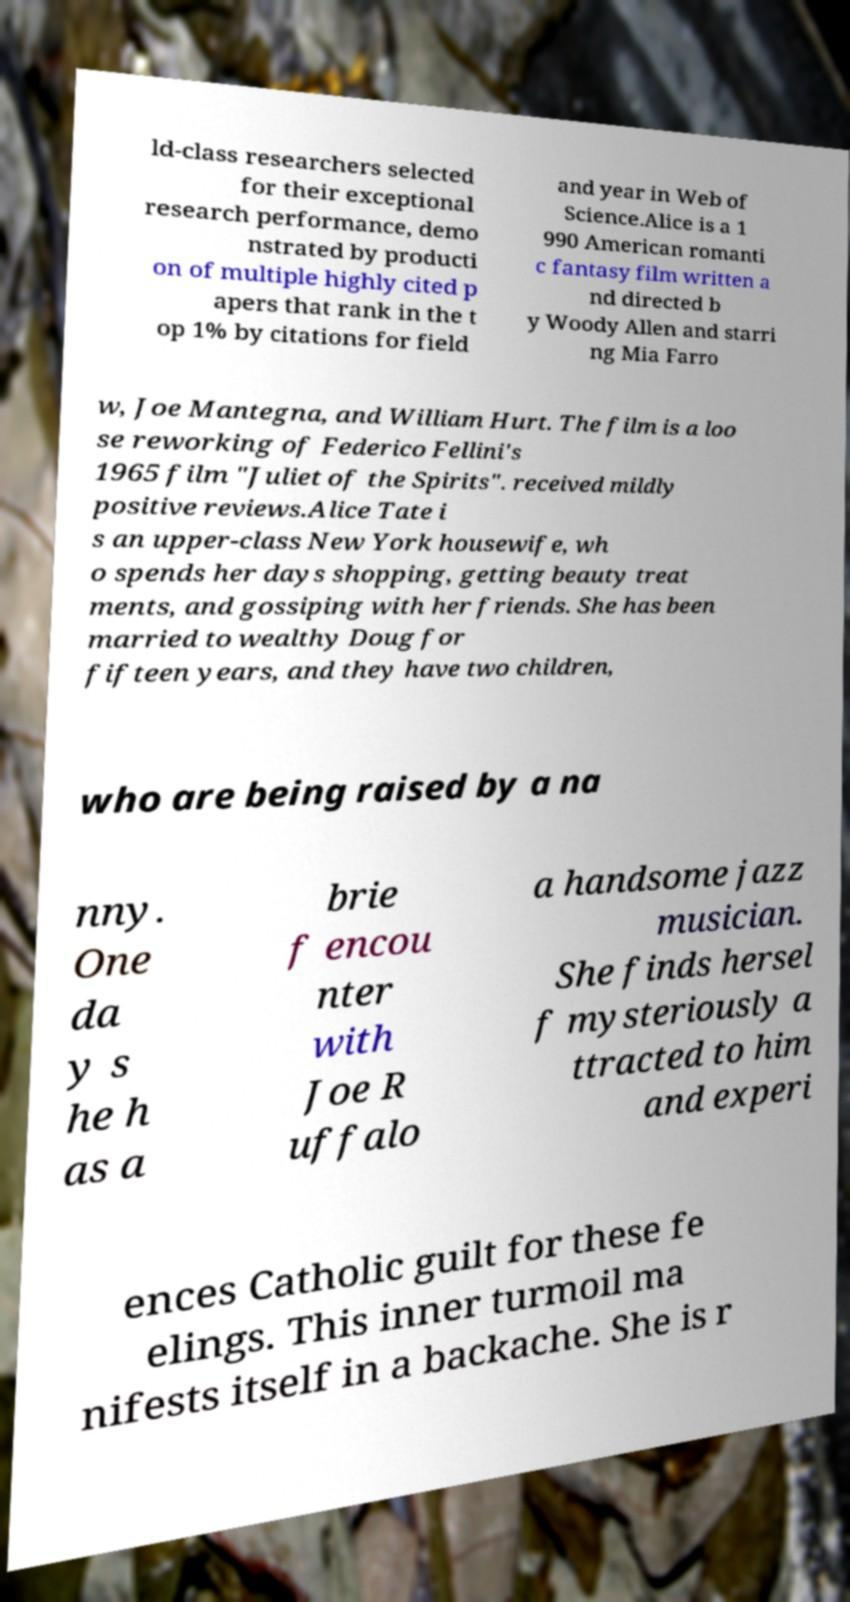Could you extract and type out the text from this image? ld-class researchers selected for their exceptional research performance, demo nstrated by producti on of multiple highly cited p apers that rank in the t op 1% by citations for field and year in Web of Science.Alice is a 1 990 American romanti c fantasy film written a nd directed b y Woody Allen and starri ng Mia Farro w, Joe Mantegna, and William Hurt. The film is a loo se reworking of Federico Fellini's 1965 film "Juliet of the Spirits". received mildly positive reviews.Alice Tate i s an upper-class New York housewife, wh o spends her days shopping, getting beauty treat ments, and gossiping with her friends. She has been married to wealthy Doug for fifteen years, and they have two children, who are being raised by a na nny. One da y s he h as a brie f encou nter with Joe R uffalo a handsome jazz musician. She finds hersel f mysteriously a ttracted to him and experi ences Catholic guilt for these fe elings. This inner turmoil ma nifests itself in a backache. She is r 